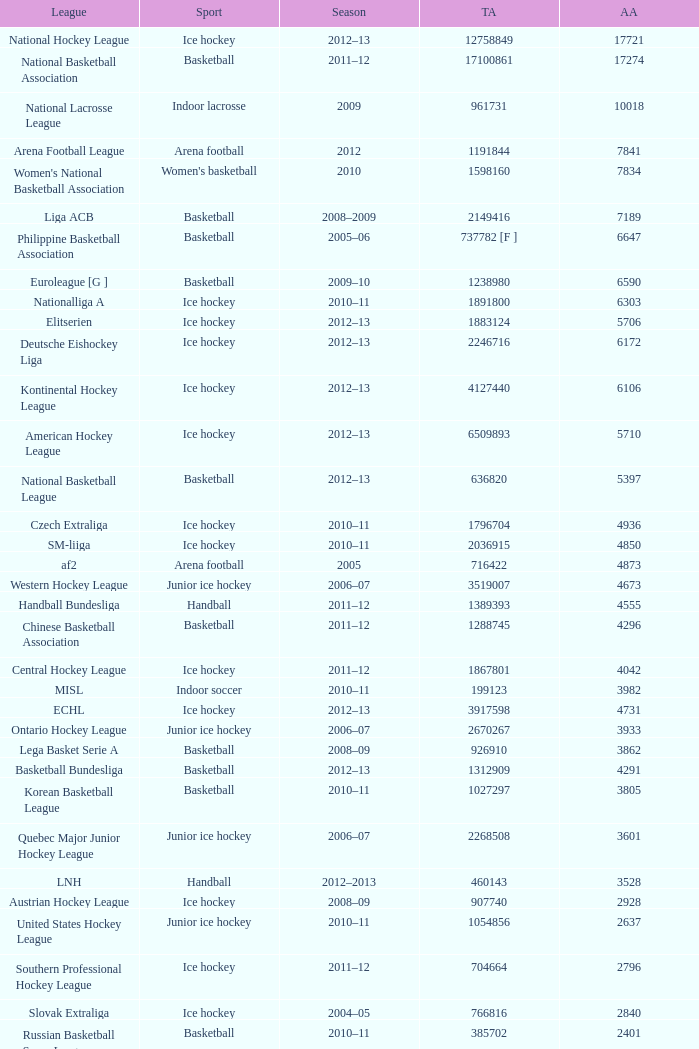What's the total attendance in rink hockey when the average attendance was smaller than 4850? 115000.0. 